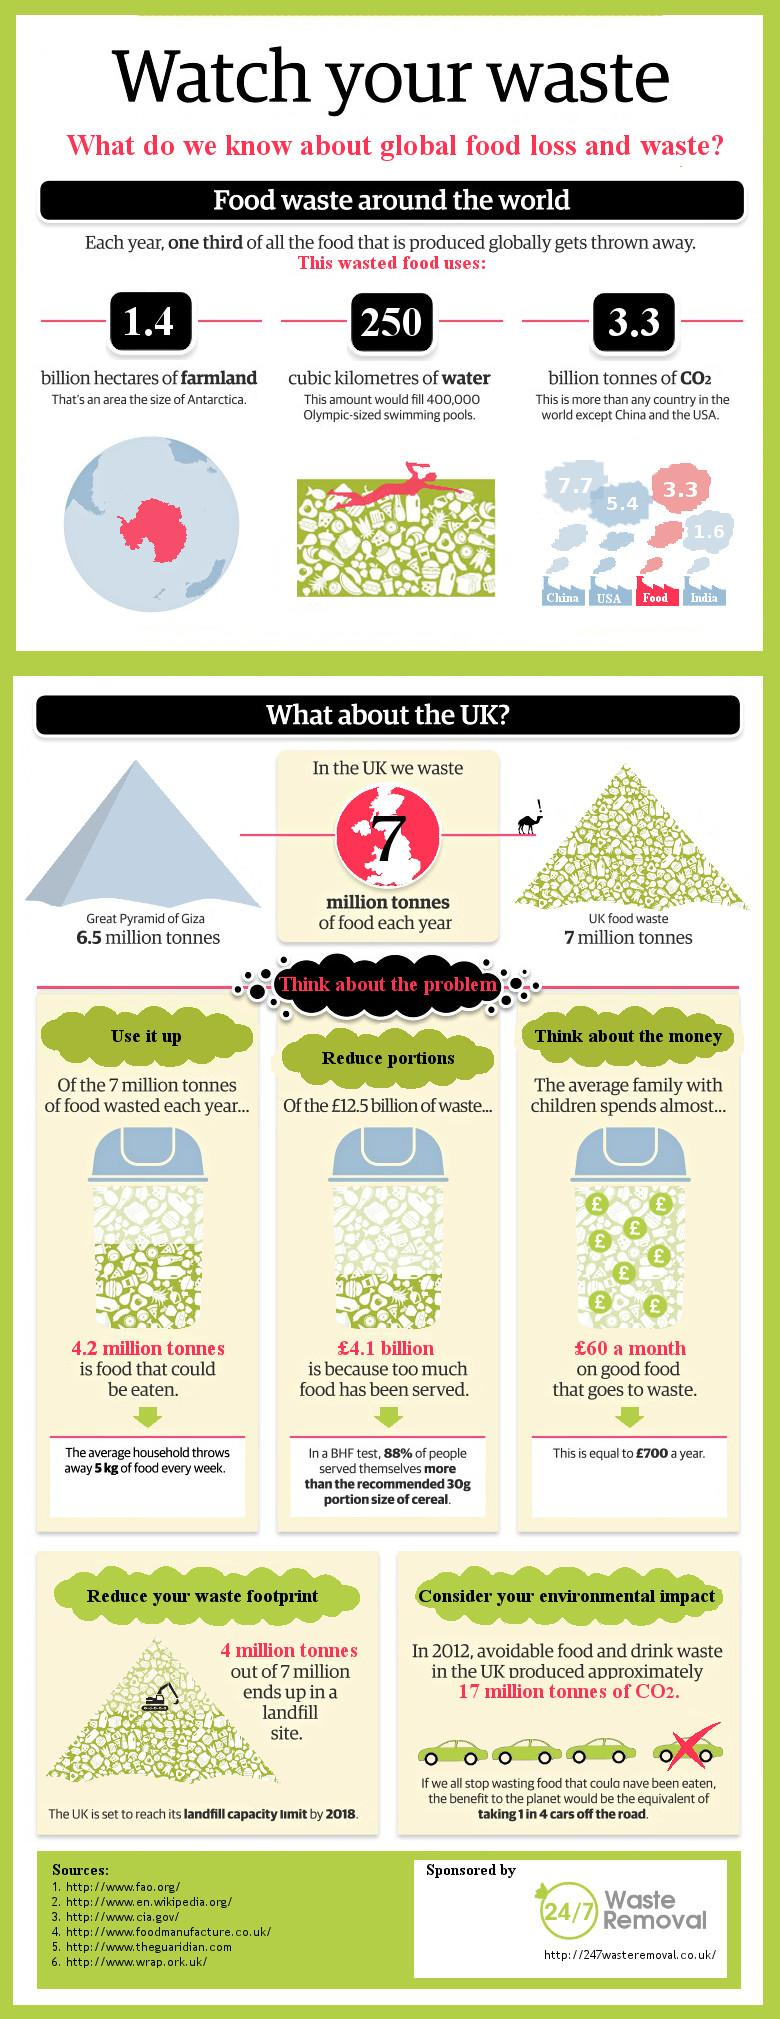List a handful of essential elements in this visual. China is the country that produces the most carbon dioxide (CO2) in the world. 